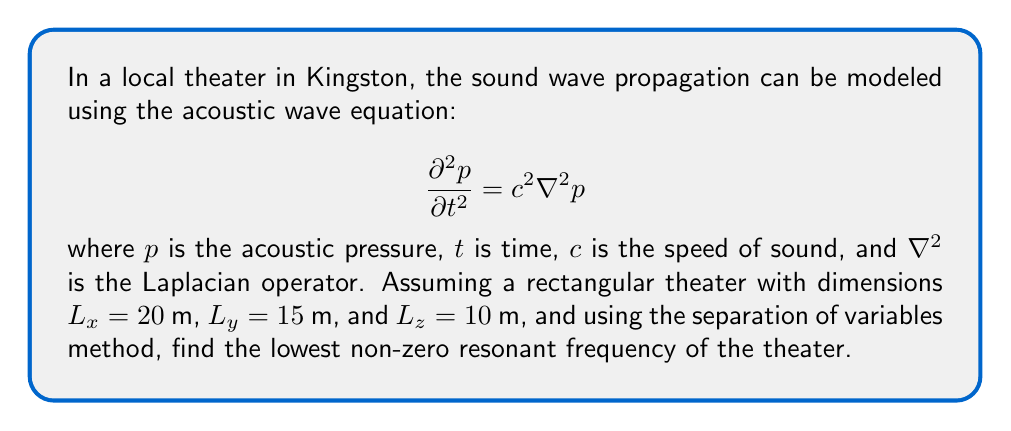Give your solution to this math problem. To solve this problem, we'll follow these steps:

1) The general solution for the acoustic wave equation in a rectangular room using separation of variables is:

   $$p(x,y,z,t) = X(x)Y(y)Z(z)T(t)$$

2) Substituting this into the wave equation and separating variables, we get:

   $$\frac{1}{X}\frac{d^2X}{dx^2} + \frac{1}{Y}\frac{d^2Y}{dy^2} + \frac{1}{Z}\frac{d^2Z}{dz^2} = -\frac{1}{c^2T}\frac{d^2T}{dt^2} = -k^2$$

   where $k$ is the wave number.

3) This leads to three separate equations for $X$, $Y$, and $Z$:

   $$\frac{d^2X}{dx^2} + k_x^2X = 0, \frac{d^2Y}{dy^2} + k_y^2Y = 0, \frac{d^2Z}{dz^2} + k_z^2Z = 0$$

   where $k_x^2 + k_y^2 + k_z^2 = k^2$

4) With the boundary conditions that pressure is zero at the walls (assuming perfectly reflective walls), we get:

   $$k_x = \frac{n_x\pi}{L_x}, k_y = \frac{n_y\pi}{L_y}, k_z = \frac{n_z\pi}{L_z}$$

   where $n_x$, $n_y$, and $n_z$ are non-negative integers.

5) The resonant frequencies are given by:

   $$f = \frac{c}{2}\sqrt{(\frac{n_x}{L_x})^2 + (\frac{n_y}{L_y})^2 + (\frac{n_z}{L_z})^2}$$

6) The lowest non-zero resonant frequency occurs when $n_x = 1$, $n_y = 0$, and $n_z = 0$:

   $$f_{min} = \frac{c}{2L_x} = \frac{343 \text{ m/s}}{2(20 \text{ m})} = 8.575 \text{ Hz}$$

   Here, we used $c = 343$ m/s, which is the speed of sound in air at room temperature.
Answer: The lowest non-zero resonant frequency of the theater is approximately 8.575 Hz. 